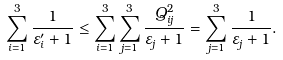<formula> <loc_0><loc_0><loc_500><loc_500>\sum _ { i = 1 } ^ { 3 } \frac { 1 } { \varepsilon _ { i } ^ { \prime } + 1 } \leq \sum _ { i = 1 } ^ { 3 } \sum _ { j = 1 } ^ { 3 } \frac { Q _ { i j } ^ { 2 } } { \varepsilon _ { j } + 1 } = \sum _ { j = 1 } ^ { 3 } \frac { 1 } { \varepsilon _ { j } + 1 } .</formula> 